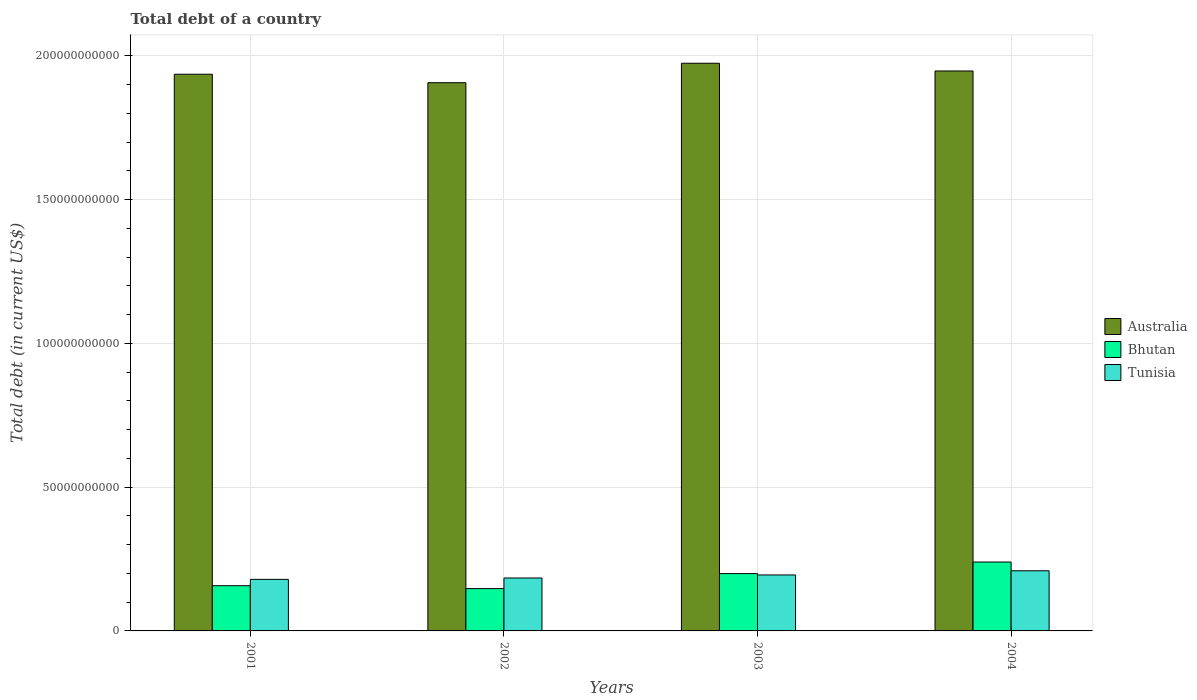How many different coloured bars are there?
Ensure brevity in your answer.  3. How many groups of bars are there?
Your answer should be very brief. 4. In how many cases, is the number of bars for a given year not equal to the number of legend labels?
Offer a very short reply. 0. What is the debt in Bhutan in 2004?
Make the answer very short. 2.40e+1. Across all years, what is the maximum debt in Tunisia?
Your answer should be very brief. 2.09e+1. Across all years, what is the minimum debt in Australia?
Ensure brevity in your answer.  1.91e+11. In which year was the debt in Tunisia maximum?
Offer a very short reply. 2004. In which year was the debt in Bhutan minimum?
Ensure brevity in your answer.  2002. What is the total debt in Tunisia in the graph?
Your answer should be compact. 7.67e+1. What is the difference between the debt in Bhutan in 2001 and that in 2004?
Your answer should be compact. -8.24e+09. What is the difference between the debt in Bhutan in 2003 and the debt in Tunisia in 2002?
Keep it short and to the point. 1.53e+09. What is the average debt in Tunisia per year?
Offer a very short reply. 1.92e+1. In the year 2003, what is the difference between the debt in Australia and debt in Bhutan?
Provide a succinct answer. 1.77e+11. In how many years, is the debt in Bhutan greater than 130000000000 US$?
Provide a short and direct response. 0. What is the ratio of the debt in Tunisia in 2001 to that in 2003?
Keep it short and to the point. 0.92. Is the debt in Tunisia in 2001 less than that in 2004?
Make the answer very short. Yes. Is the difference between the debt in Australia in 2001 and 2002 greater than the difference between the debt in Bhutan in 2001 and 2002?
Give a very brief answer. Yes. What is the difference between the highest and the second highest debt in Bhutan?
Your answer should be very brief. 4.03e+09. What is the difference between the highest and the lowest debt in Australia?
Ensure brevity in your answer.  6.76e+09. In how many years, is the debt in Australia greater than the average debt in Australia taken over all years?
Ensure brevity in your answer.  2. What does the 3rd bar from the left in 2003 represents?
Your response must be concise. Tunisia. What does the 2nd bar from the right in 2004 represents?
Ensure brevity in your answer.  Bhutan. How many years are there in the graph?
Keep it short and to the point. 4. Does the graph contain any zero values?
Make the answer very short. No. Where does the legend appear in the graph?
Keep it short and to the point. Center right. How many legend labels are there?
Your response must be concise. 3. What is the title of the graph?
Your response must be concise. Total debt of a country. What is the label or title of the X-axis?
Offer a very short reply. Years. What is the label or title of the Y-axis?
Keep it short and to the point. Total debt (in current US$). What is the Total debt (in current US$) of Australia in 2001?
Offer a terse response. 1.94e+11. What is the Total debt (in current US$) in Bhutan in 2001?
Provide a short and direct response. 1.57e+1. What is the Total debt (in current US$) of Tunisia in 2001?
Give a very brief answer. 1.79e+1. What is the Total debt (in current US$) in Australia in 2002?
Your answer should be compact. 1.91e+11. What is the Total debt (in current US$) of Bhutan in 2002?
Make the answer very short. 1.47e+1. What is the Total debt (in current US$) of Tunisia in 2002?
Ensure brevity in your answer.  1.84e+1. What is the Total debt (in current US$) in Australia in 2003?
Provide a succinct answer. 1.97e+11. What is the Total debt (in current US$) of Bhutan in 2003?
Make the answer very short. 1.99e+1. What is the Total debt (in current US$) in Tunisia in 2003?
Your answer should be very brief. 1.95e+1. What is the Total debt (in current US$) of Australia in 2004?
Make the answer very short. 1.95e+11. What is the Total debt (in current US$) of Bhutan in 2004?
Offer a very short reply. 2.40e+1. What is the Total debt (in current US$) in Tunisia in 2004?
Offer a terse response. 2.09e+1. Across all years, what is the maximum Total debt (in current US$) in Australia?
Offer a terse response. 1.97e+11. Across all years, what is the maximum Total debt (in current US$) of Bhutan?
Offer a very short reply. 2.40e+1. Across all years, what is the maximum Total debt (in current US$) of Tunisia?
Offer a very short reply. 2.09e+1. Across all years, what is the minimum Total debt (in current US$) of Australia?
Your answer should be compact. 1.91e+11. Across all years, what is the minimum Total debt (in current US$) of Bhutan?
Your answer should be very brief. 1.47e+1. Across all years, what is the minimum Total debt (in current US$) of Tunisia?
Give a very brief answer. 1.79e+1. What is the total Total debt (in current US$) in Australia in the graph?
Keep it short and to the point. 7.76e+11. What is the total Total debt (in current US$) in Bhutan in the graph?
Your answer should be compact. 7.43e+1. What is the total Total debt (in current US$) in Tunisia in the graph?
Provide a short and direct response. 7.67e+1. What is the difference between the Total debt (in current US$) of Australia in 2001 and that in 2002?
Offer a very short reply. 2.95e+09. What is the difference between the Total debt (in current US$) of Bhutan in 2001 and that in 2002?
Offer a terse response. 1.01e+09. What is the difference between the Total debt (in current US$) in Tunisia in 2001 and that in 2002?
Your response must be concise. -4.77e+08. What is the difference between the Total debt (in current US$) in Australia in 2001 and that in 2003?
Give a very brief answer. -3.81e+09. What is the difference between the Total debt (in current US$) of Bhutan in 2001 and that in 2003?
Ensure brevity in your answer.  -4.21e+09. What is the difference between the Total debt (in current US$) in Tunisia in 2001 and that in 2003?
Your answer should be very brief. -1.54e+09. What is the difference between the Total debt (in current US$) in Australia in 2001 and that in 2004?
Your response must be concise. -1.13e+09. What is the difference between the Total debt (in current US$) in Bhutan in 2001 and that in 2004?
Ensure brevity in your answer.  -8.24e+09. What is the difference between the Total debt (in current US$) in Tunisia in 2001 and that in 2004?
Ensure brevity in your answer.  -2.98e+09. What is the difference between the Total debt (in current US$) of Australia in 2002 and that in 2003?
Keep it short and to the point. -6.76e+09. What is the difference between the Total debt (in current US$) in Bhutan in 2002 and that in 2003?
Give a very brief answer. -5.22e+09. What is the difference between the Total debt (in current US$) in Tunisia in 2002 and that in 2003?
Make the answer very short. -1.06e+09. What is the difference between the Total debt (in current US$) in Australia in 2002 and that in 2004?
Your answer should be very brief. -4.08e+09. What is the difference between the Total debt (in current US$) of Bhutan in 2002 and that in 2004?
Keep it short and to the point. -9.24e+09. What is the difference between the Total debt (in current US$) in Tunisia in 2002 and that in 2004?
Provide a succinct answer. -2.51e+09. What is the difference between the Total debt (in current US$) in Australia in 2003 and that in 2004?
Keep it short and to the point. 2.69e+09. What is the difference between the Total debt (in current US$) in Bhutan in 2003 and that in 2004?
Provide a succinct answer. -4.03e+09. What is the difference between the Total debt (in current US$) in Tunisia in 2003 and that in 2004?
Provide a short and direct response. -1.45e+09. What is the difference between the Total debt (in current US$) of Australia in 2001 and the Total debt (in current US$) of Bhutan in 2002?
Your response must be concise. 1.79e+11. What is the difference between the Total debt (in current US$) in Australia in 2001 and the Total debt (in current US$) in Tunisia in 2002?
Give a very brief answer. 1.75e+11. What is the difference between the Total debt (in current US$) in Bhutan in 2001 and the Total debt (in current US$) in Tunisia in 2002?
Make the answer very short. -2.68e+09. What is the difference between the Total debt (in current US$) of Australia in 2001 and the Total debt (in current US$) of Bhutan in 2003?
Your answer should be very brief. 1.74e+11. What is the difference between the Total debt (in current US$) in Australia in 2001 and the Total debt (in current US$) in Tunisia in 2003?
Give a very brief answer. 1.74e+11. What is the difference between the Total debt (in current US$) in Bhutan in 2001 and the Total debt (in current US$) in Tunisia in 2003?
Give a very brief answer. -3.74e+09. What is the difference between the Total debt (in current US$) in Australia in 2001 and the Total debt (in current US$) in Bhutan in 2004?
Offer a terse response. 1.70e+11. What is the difference between the Total debt (in current US$) of Australia in 2001 and the Total debt (in current US$) of Tunisia in 2004?
Give a very brief answer. 1.73e+11. What is the difference between the Total debt (in current US$) in Bhutan in 2001 and the Total debt (in current US$) in Tunisia in 2004?
Offer a very short reply. -5.19e+09. What is the difference between the Total debt (in current US$) of Australia in 2002 and the Total debt (in current US$) of Bhutan in 2003?
Offer a terse response. 1.71e+11. What is the difference between the Total debt (in current US$) of Australia in 2002 and the Total debt (in current US$) of Tunisia in 2003?
Your answer should be very brief. 1.71e+11. What is the difference between the Total debt (in current US$) of Bhutan in 2002 and the Total debt (in current US$) of Tunisia in 2003?
Offer a very short reply. -4.75e+09. What is the difference between the Total debt (in current US$) in Australia in 2002 and the Total debt (in current US$) in Bhutan in 2004?
Keep it short and to the point. 1.67e+11. What is the difference between the Total debt (in current US$) of Australia in 2002 and the Total debt (in current US$) of Tunisia in 2004?
Ensure brevity in your answer.  1.70e+11. What is the difference between the Total debt (in current US$) of Bhutan in 2002 and the Total debt (in current US$) of Tunisia in 2004?
Offer a terse response. -6.19e+09. What is the difference between the Total debt (in current US$) in Australia in 2003 and the Total debt (in current US$) in Bhutan in 2004?
Your answer should be very brief. 1.73e+11. What is the difference between the Total debt (in current US$) of Australia in 2003 and the Total debt (in current US$) of Tunisia in 2004?
Make the answer very short. 1.76e+11. What is the difference between the Total debt (in current US$) in Bhutan in 2003 and the Total debt (in current US$) in Tunisia in 2004?
Offer a terse response. -9.79e+08. What is the average Total debt (in current US$) of Australia per year?
Ensure brevity in your answer.  1.94e+11. What is the average Total debt (in current US$) of Bhutan per year?
Make the answer very short. 1.86e+1. What is the average Total debt (in current US$) of Tunisia per year?
Ensure brevity in your answer.  1.92e+1. In the year 2001, what is the difference between the Total debt (in current US$) of Australia and Total debt (in current US$) of Bhutan?
Provide a succinct answer. 1.78e+11. In the year 2001, what is the difference between the Total debt (in current US$) in Australia and Total debt (in current US$) in Tunisia?
Your answer should be compact. 1.76e+11. In the year 2001, what is the difference between the Total debt (in current US$) in Bhutan and Total debt (in current US$) in Tunisia?
Provide a short and direct response. -2.20e+09. In the year 2002, what is the difference between the Total debt (in current US$) of Australia and Total debt (in current US$) of Bhutan?
Offer a very short reply. 1.76e+11. In the year 2002, what is the difference between the Total debt (in current US$) of Australia and Total debt (in current US$) of Tunisia?
Provide a short and direct response. 1.72e+11. In the year 2002, what is the difference between the Total debt (in current US$) of Bhutan and Total debt (in current US$) of Tunisia?
Your answer should be very brief. -3.69e+09. In the year 2003, what is the difference between the Total debt (in current US$) in Australia and Total debt (in current US$) in Bhutan?
Provide a short and direct response. 1.77e+11. In the year 2003, what is the difference between the Total debt (in current US$) of Australia and Total debt (in current US$) of Tunisia?
Keep it short and to the point. 1.78e+11. In the year 2003, what is the difference between the Total debt (in current US$) in Bhutan and Total debt (in current US$) in Tunisia?
Provide a succinct answer. 4.68e+08. In the year 2004, what is the difference between the Total debt (in current US$) of Australia and Total debt (in current US$) of Bhutan?
Ensure brevity in your answer.  1.71e+11. In the year 2004, what is the difference between the Total debt (in current US$) of Australia and Total debt (in current US$) of Tunisia?
Your answer should be compact. 1.74e+11. In the year 2004, what is the difference between the Total debt (in current US$) in Bhutan and Total debt (in current US$) in Tunisia?
Your response must be concise. 3.05e+09. What is the ratio of the Total debt (in current US$) in Australia in 2001 to that in 2002?
Keep it short and to the point. 1.02. What is the ratio of the Total debt (in current US$) in Bhutan in 2001 to that in 2002?
Your response must be concise. 1.07. What is the ratio of the Total debt (in current US$) in Tunisia in 2001 to that in 2002?
Your response must be concise. 0.97. What is the ratio of the Total debt (in current US$) in Australia in 2001 to that in 2003?
Make the answer very short. 0.98. What is the ratio of the Total debt (in current US$) of Bhutan in 2001 to that in 2003?
Provide a short and direct response. 0.79. What is the ratio of the Total debt (in current US$) of Tunisia in 2001 to that in 2003?
Make the answer very short. 0.92. What is the ratio of the Total debt (in current US$) in Australia in 2001 to that in 2004?
Your response must be concise. 0.99. What is the ratio of the Total debt (in current US$) of Bhutan in 2001 to that in 2004?
Your response must be concise. 0.66. What is the ratio of the Total debt (in current US$) of Tunisia in 2001 to that in 2004?
Offer a terse response. 0.86. What is the ratio of the Total debt (in current US$) of Australia in 2002 to that in 2003?
Offer a very short reply. 0.97. What is the ratio of the Total debt (in current US$) in Bhutan in 2002 to that in 2003?
Make the answer very short. 0.74. What is the ratio of the Total debt (in current US$) of Tunisia in 2002 to that in 2003?
Your response must be concise. 0.95. What is the ratio of the Total debt (in current US$) in Australia in 2002 to that in 2004?
Offer a terse response. 0.98. What is the ratio of the Total debt (in current US$) in Bhutan in 2002 to that in 2004?
Keep it short and to the point. 0.61. What is the ratio of the Total debt (in current US$) in Tunisia in 2002 to that in 2004?
Ensure brevity in your answer.  0.88. What is the ratio of the Total debt (in current US$) in Australia in 2003 to that in 2004?
Give a very brief answer. 1.01. What is the ratio of the Total debt (in current US$) of Bhutan in 2003 to that in 2004?
Your response must be concise. 0.83. What is the ratio of the Total debt (in current US$) in Tunisia in 2003 to that in 2004?
Offer a terse response. 0.93. What is the difference between the highest and the second highest Total debt (in current US$) of Australia?
Offer a terse response. 2.69e+09. What is the difference between the highest and the second highest Total debt (in current US$) in Bhutan?
Your answer should be very brief. 4.03e+09. What is the difference between the highest and the second highest Total debt (in current US$) of Tunisia?
Provide a succinct answer. 1.45e+09. What is the difference between the highest and the lowest Total debt (in current US$) in Australia?
Provide a succinct answer. 6.76e+09. What is the difference between the highest and the lowest Total debt (in current US$) in Bhutan?
Provide a succinct answer. 9.24e+09. What is the difference between the highest and the lowest Total debt (in current US$) in Tunisia?
Keep it short and to the point. 2.98e+09. 